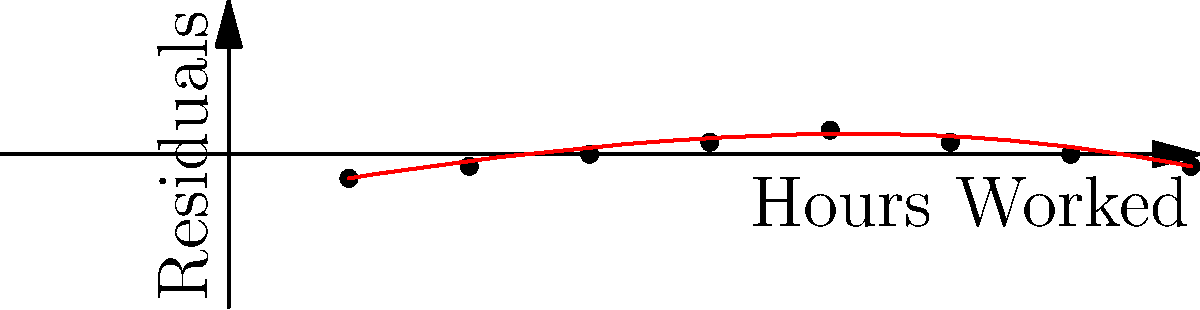As a data scientist in your Fortune 500 company, you've conducted a multiple regression analysis to investigate factors affecting employee productivity. One of the predictors in your model is "Hours Worked". The residual plot for this predictor is shown above. What does this residual plot suggest about the relationship between Hours Worked and employee productivity, and what action should you consider taking to improve the model? To interpret this residual plot and determine the appropriate action, let's follow these steps:

1. Observe the pattern: The residuals show a clear curved pattern rather than being randomly scattered around zero.

2. Interpret the pattern: This curved pattern indicates a non-linear relationship between Hours Worked and the dependent variable (employee productivity).

3. Understand the implications: The current linear model is not capturing the true relationship between Hours Worked and productivity. This suggests that the model's assumptions of linearity are violated.

4. Assess the relationship: The curve suggests that productivity increases with hours worked up to a point, then begins to decrease. This could indicate diminishing returns or fatigue effects.

5. Consider the model's performance: The presence of this pattern means the current model is likely underestimating productivity for mid-range hours and overestimating it for low and high hours worked.

6. Determine appropriate action: To improve the model, we should consider adding a quadratic term (Hours Worked squared) to the regression equation. This will allow the model to capture the curvilinear relationship observed in the residual plot.

7. Expected outcome: Adding the quadratic term should result in a more accurate model with residuals that are more randomly scattered around zero.
Answer: The plot suggests a non-linear relationship between Hours Worked and productivity. Consider adding a quadratic term (Hours Worked squared) to the model. 